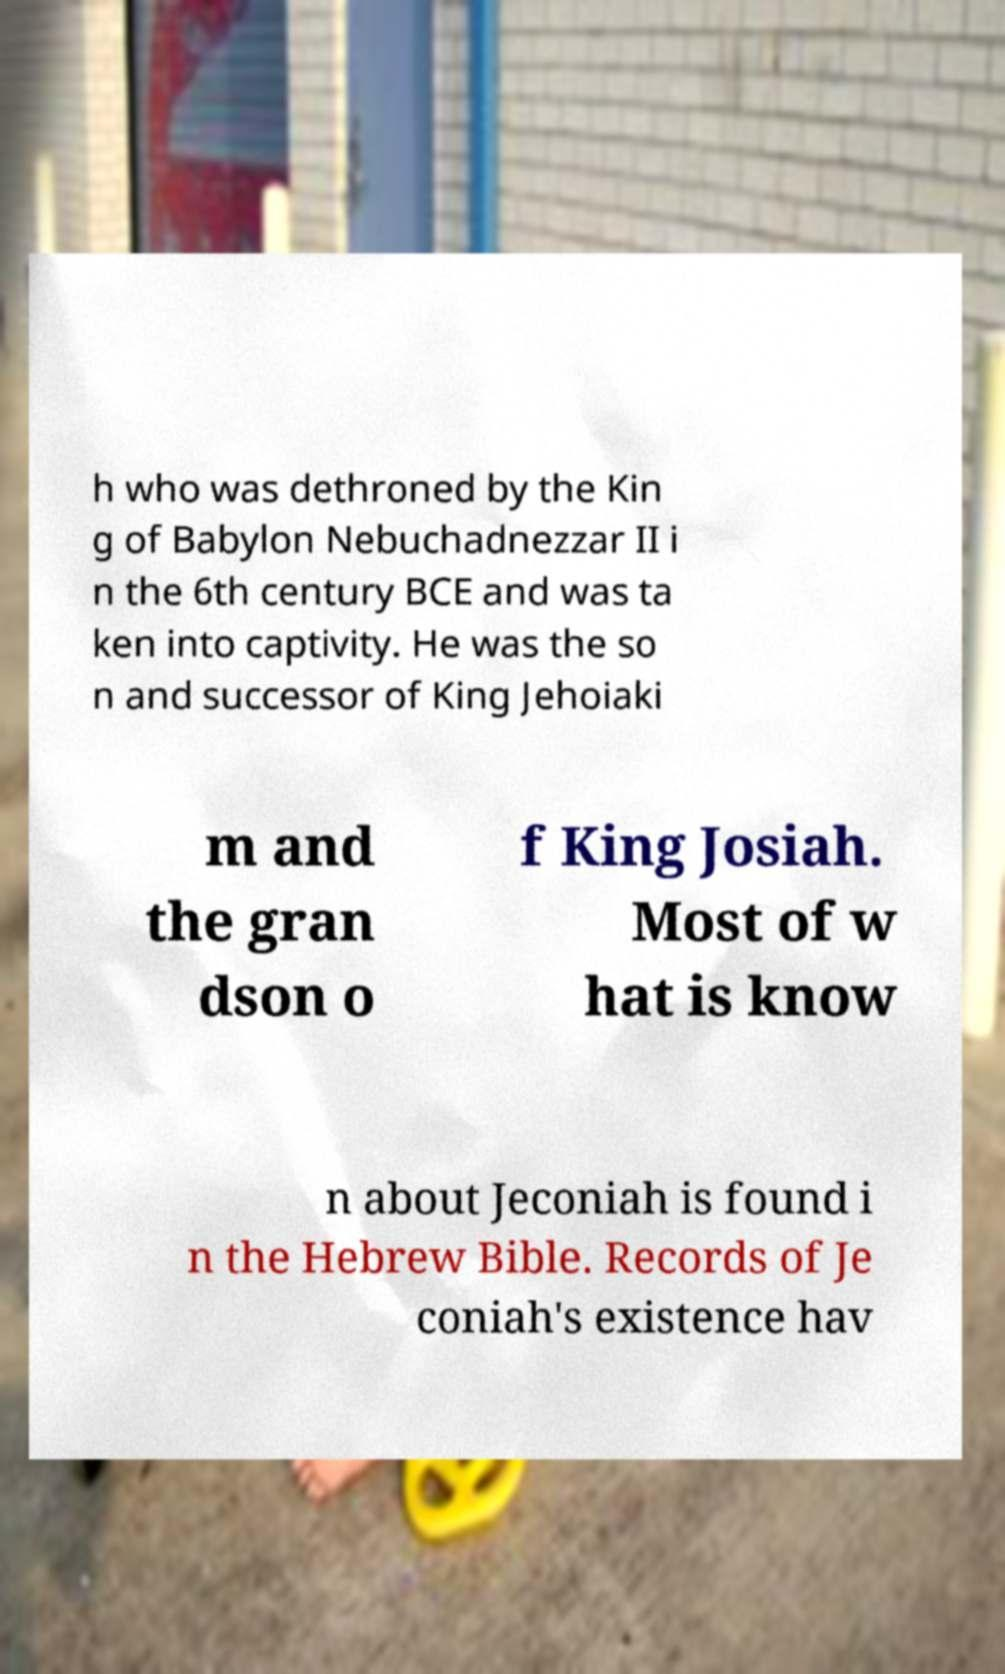There's text embedded in this image that I need extracted. Can you transcribe it verbatim? h who was dethroned by the Kin g of Babylon Nebuchadnezzar II i n the 6th century BCE and was ta ken into captivity. He was the so n and successor of King Jehoiaki m and the gran dson o f King Josiah. Most of w hat is know n about Jeconiah is found i n the Hebrew Bible. Records of Je coniah's existence hav 